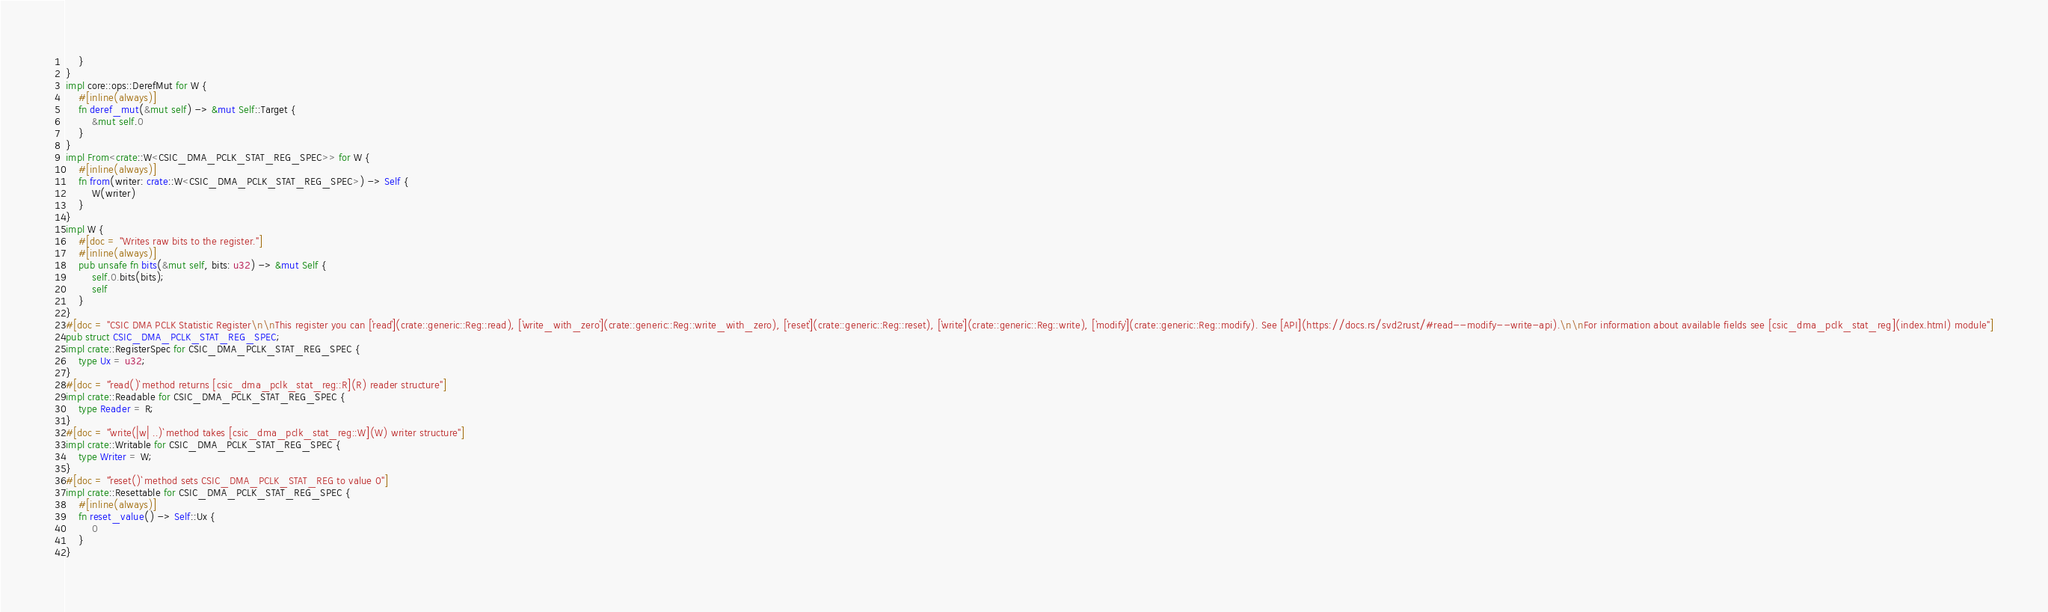<code> <loc_0><loc_0><loc_500><loc_500><_Rust_>    }
}
impl core::ops::DerefMut for W {
    #[inline(always)]
    fn deref_mut(&mut self) -> &mut Self::Target {
        &mut self.0
    }
}
impl From<crate::W<CSIC_DMA_PCLK_STAT_REG_SPEC>> for W {
    #[inline(always)]
    fn from(writer: crate::W<CSIC_DMA_PCLK_STAT_REG_SPEC>) -> Self {
        W(writer)
    }
}
impl W {
    #[doc = "Writes raw bits to the register."]
    #[inline(always)]
    pub unsafe fn bits(&mut self, bits: u32) -> &mut Self {
        self.0.bits(bits);
        self
    }
}
#[doc = "CSIC DMA PCLK Statistic Register\n\nThis register you can [`read`](crate::generic::Reg::read), [`write_with_zero`](crate::generic::Reg::write_with_zero), [`reset`](crate::generic::Reg::reset), [`write`](crate::generic::Reg::write), [`modify`](crate::generic::Reg::modify). See [API](https://docs.rs/svd2rust/#read--modify--write-api).\n\nFor information about available fields see [csic_dma_pclk_stat_reg](index.html) module"]
pub struct CSIC_DMA_PCLK_STAT_REG_SPEC;
impl crate::RegisterSpec for CSIC_DMA_PCLK_STAT_REG_SPEC {
    type Ux = u32;
}
#[doc = "`read()` method returns [csic_dma_pclk_stat_reg::R](R) reader structure"]
impl crate::Readable for CSIC_DMA_PCLK_STAT_REG_SPEC {
    type Reader = R;
}
#[doc = "`write(|w| ..)` method takes [csic_dma_pclk_stat_reg::W](W) writer structure"]
impl crate::Writable for CSIC_DMA_PCLK_STAT_REG_SPEC {
    type Writer = W;
}
#[doc = "`reset()` method sets CSIC_DMA_PCLK_STAT_REG to value 0"]
impl crate::Resettable for CSIC_DMA_PCLK_STAT_REG_SPEC {
    #[inline(always)]
    fn reset_value() -> Self::Ux {
        0
    }
}
</code> 